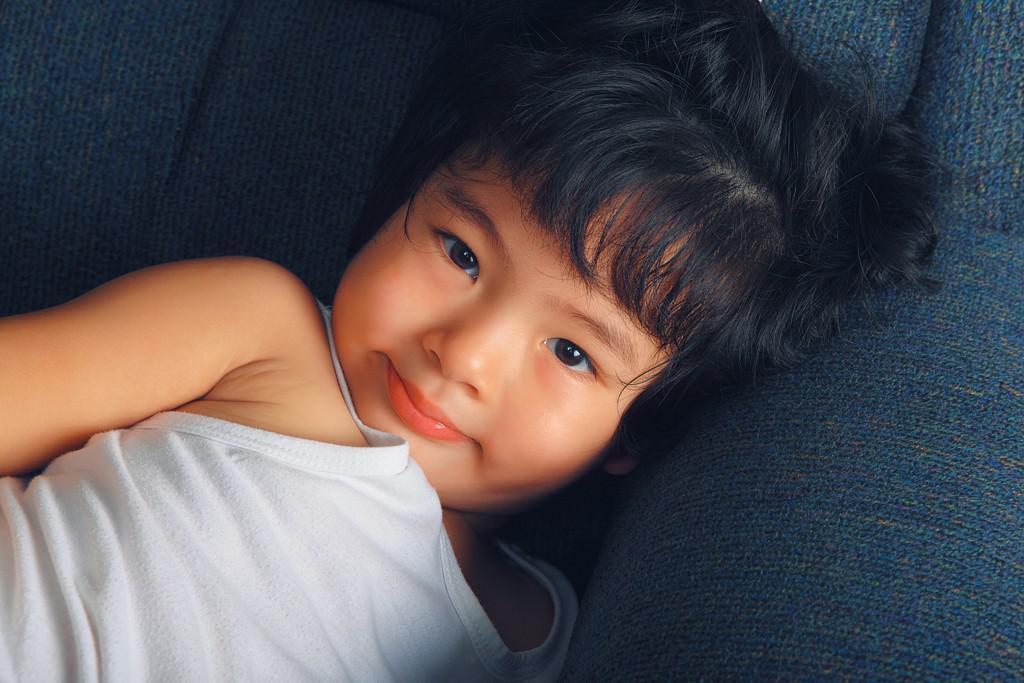How would you summarize this image in a sentence or two? In this image I can see the person laying on the blue color object and the person is wearing white color dress. 